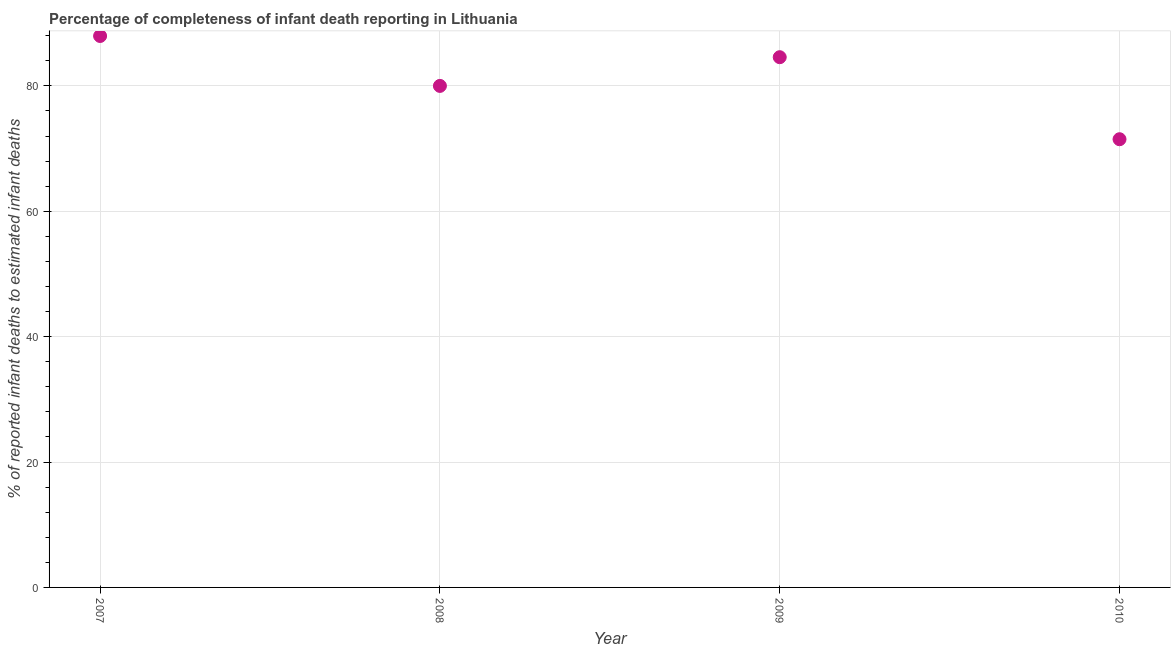What is the completeness of infant death reporting in 2007?
Provide a succinct answer. 87.96. Across all years, what is the maximum completeness of infant death reporting?
Provide a short and direct response. 87.96. Across all years, what is the minimum completeness of infant death reporting?
Ensure brevity in your answer.  71.5. In which year was the completeness of infant death reporting maximum?
Offer a terse response. 2007. In which year was the completeness of infant death reporting minimum?
Provide a succinct answer. 2010. What is the sum of the completeness of infant death reporting?
Make the answer very short. 324.04. What is the difference between the completeness of infant death reporting in 2008 and 2009?
Offer a very short reply. -4.58. What is the average completeness of infant death reporting per year?
Your answer should be compact. 81.01. What is the median completeness of infant death reporting?
Provide a succinct answer. 82.29. In how many years, is the completeness of infant death reporting greater than 4 %?
Your response must be concise. 4. What is the ratio of the completeness of infant death reporting in 2009 to that in 2010?
Your response must be concise. 1.18. What is the difference between the highest and the second highest completeness of infant death reporting?
Provide a short and direct response. 3.38. Is the sum of the completeness of infant death reporting in 2008 and 2010 greater than the maximum completeness of infant death reporting across all years?
Your answer should be compact. Yes. What is the difference between the highest and the lowest completeness of infant death reporting?
Your answer should be compact. 16.47. Does the completeness of infant death reporting monotonically increase over the years?
Make the answer very short. No. How many years are there in the graph?
Provide a succinct answer. 4. What is the difference between two consecutive major ticks on the Y-axis?
Make the answer very short. 20. What is the title of the graph?
Give a very brief answer. Percentage of completeness of infant death reporting in Lithuania. What is the label or title of the Y-axis?
Offer a terse response. % of reported infant deaths to estimated infant deaths. What is the % of reported infant deaths to estimated infant deaths in 2007?
Offer a terse response. 87.96. What is the % of reported infant deaths to estimated infant deaths in 2009?
Make the answer very short. 84.58. What is the % of reported infant deaths to estimated infant deaths in 2010?
Ensure brevity in your answer.  71.5. What is the difference between the % of reported infant deaths to estimated infant deaths in 2007 and 2008?
Offer a very short reply. 7.96. What is the difference between the % of reported infant deaths to estimated infant deaths in 2007 and 2009?
Offer a terse response. 3.38. What is the difference between the % of reported infant deaths to estimated infant deaths in 2007 and 2010?
Keep it short and to the point. 16.47. What is the difference between the % of reported infant deaths to estimated infant deaths in 2008 and 2009?
Give a very brief answer. -4.58. What is the difference between the % of reported infant deaths to estimated infant deaths in 2008 and 2010?
Offer a very short reply. 8.5. What is the difference between the % of reported infant deaths to estimated infant deaths in 2009 and 2010?
Your answer should be compact. 13.08. What is the ratio of the % of reported infant deaths to estimated infant deaths in 2007 to that in 2009?
Your answer should be very brief. 1.04. What is the ratio of the % of reported infant deaths to estimated infant deaths in 2007 to that in 2010?
Your answer should be very brief. 1.23. What is the ratio of the % of reported infant deaths to estimated infant deaths in 2008 to that in 2009?
Your answer should be compact. 0.95. What is the ratio of the % of reported infant deaths to estimated infant deaths in 2008 to that in 2010?
Ensure brevity in your answer.  1.12. What is the ratio of the % of reported infant deaths to estimated infant deaths in 2009 to that in 2010?
Keep it short and to the point. 1.18. 